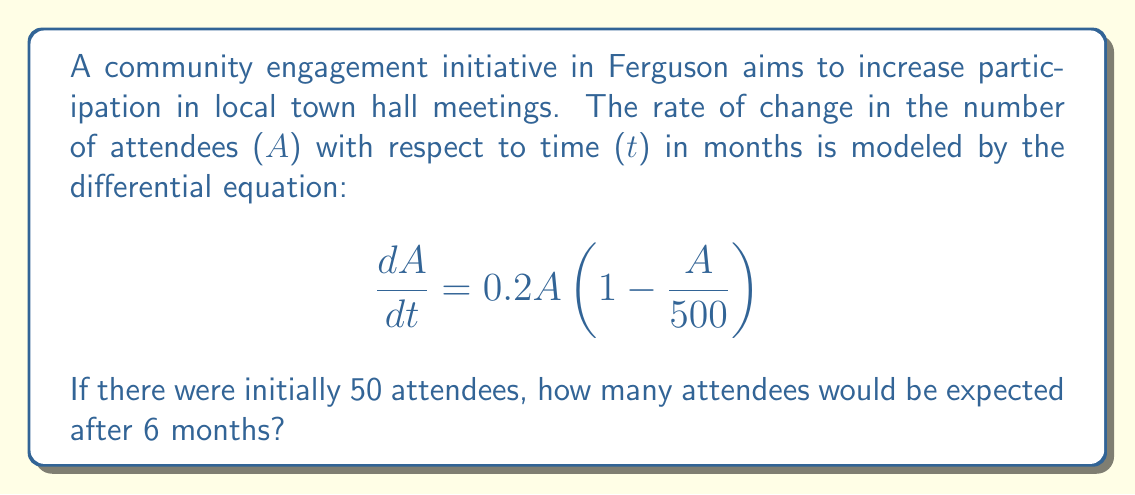Can you answer this question? To solve this problem, we need to recognize that this is a logistic growth model and solve the differential equation.

1) The given equation is a separable differential equation. Let's separate the variables:

   $$\frac{dA}{A(1 - \frac{A}{500})} = 0.2dt$$

2) Integrate both sides:

   $$\int \frac{dA}{A(1 - \frac{A}{500})} = \int 0.2dt$$

3) The left side can be integrated using partial fractions:

   $$\ln|A| - \ln|500-A| = 0.2t + C$$

4) Simplify:

   $$\ln|\frac{A}{500-A}| = 0.2t + C$$

5) Exponentiate both sides:

   $$\frac{A}{500-A} = Ke^{0.2t}$$, where $K = e^C$

6) Solve for A:

   $$A = \frac{500Ke^{0.2t}}{1 + Ke^{0.2t}}$$

7) Use the initial condition A(0) = 50 to find K:

   $$50 = \frac{500K}{1 + K}$$
   $$K = \frac{1}{9}$$

8) Substitute this back into our solution:

   $$A = \frac{500(\frac{1}{9})e^{0.2t}}{1 + (\frac{1}{9})e^{0.2t}} = \frac{500}{9e^{-0.2t} + 1}$$

9) Now, we can find A(6) by substituting t = 6:

   $$A(6) = \frac{500}{9e^{-0.2(6)} + 1} \approx 167.8$$
Answer: After 6 months, approximately 168 attendees would be expected at the town hall meetings. 